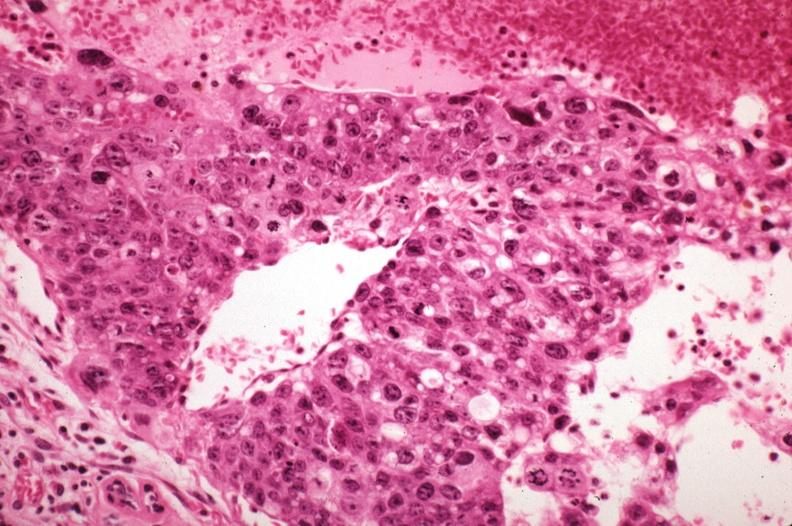what is mitotic figures sickled?
Answer the question using a single word or phrase. Red cells in vessels well shown 